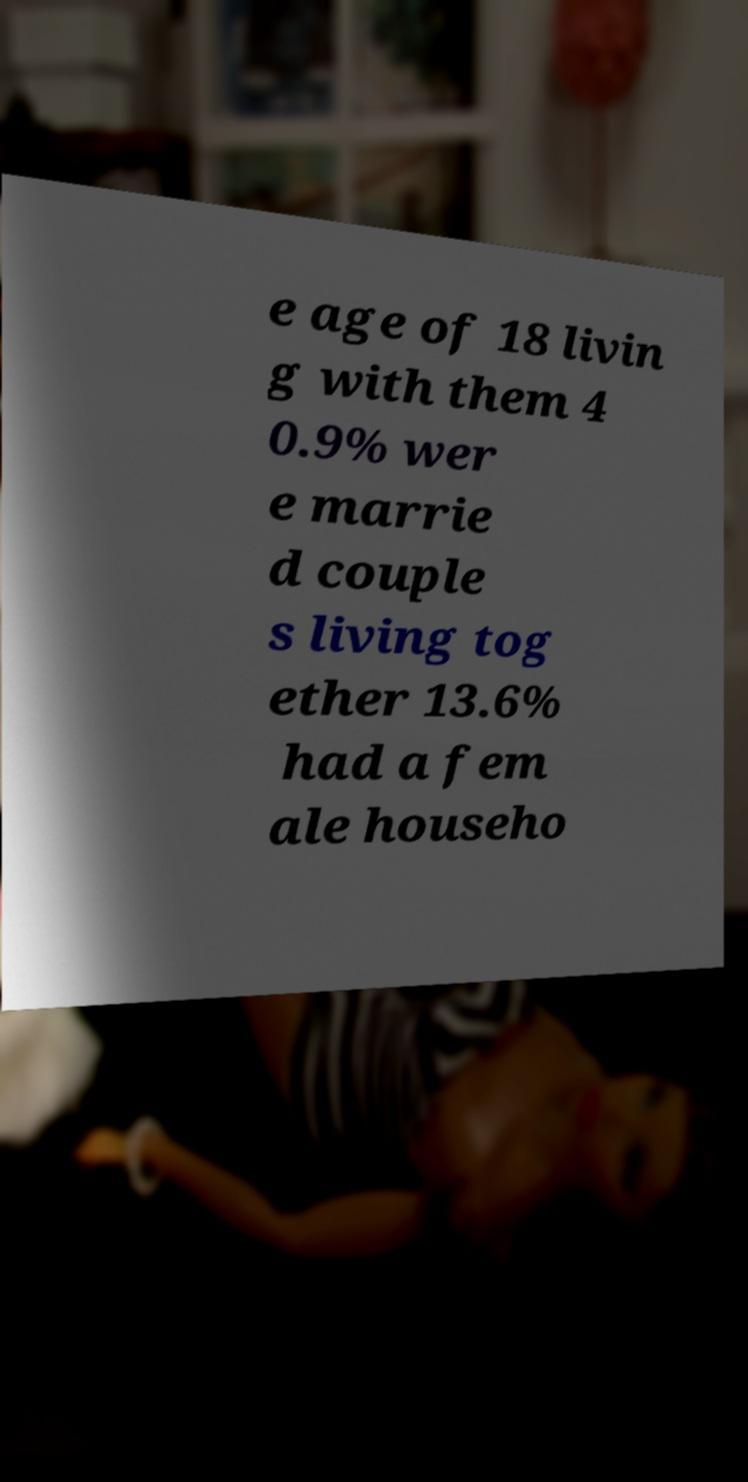Please identify and transcribe the text found in this image. e age of 18 livin g with them 4 0.9% wer e marrie d couple s living tog ether 13.6% had a fem ale househo 